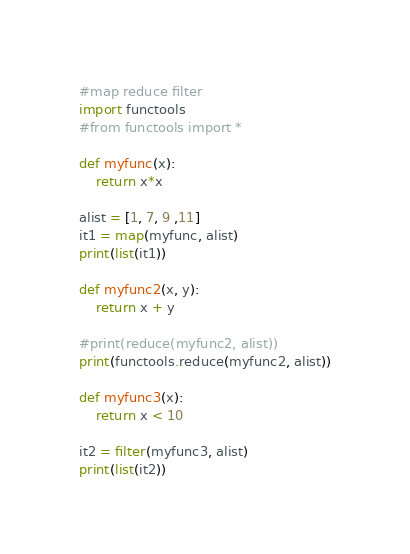<code> <loc_0><loc_0><loc_500><loc_500><_Python_>#map reduce filter
import functools
#from functools import *

def myfunc(x):
    return x*x

alist = [1, 7, 9 ,11]
it1 = map(myfunc, alist)
print(list(it1))

def myfunc2(x, y):
    return x + y

#print(reduce(myfunc2, alist))
print(functools.reduce(myfunc2, alist))

def myfunc3(x):
    return x < 10

it2 = filter(myfunc3, alist)
print(list(it2))

</code> 